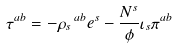<formula> <loc_0><loc_0><loc_500><loc_500>\tau ^ { a b } = - \rho _ { s } \, ^ { a b } e ^ { s } - \frac { N ^ { s } } { \phi } \iota _ { s } \pi ^ { a b }</formula> 